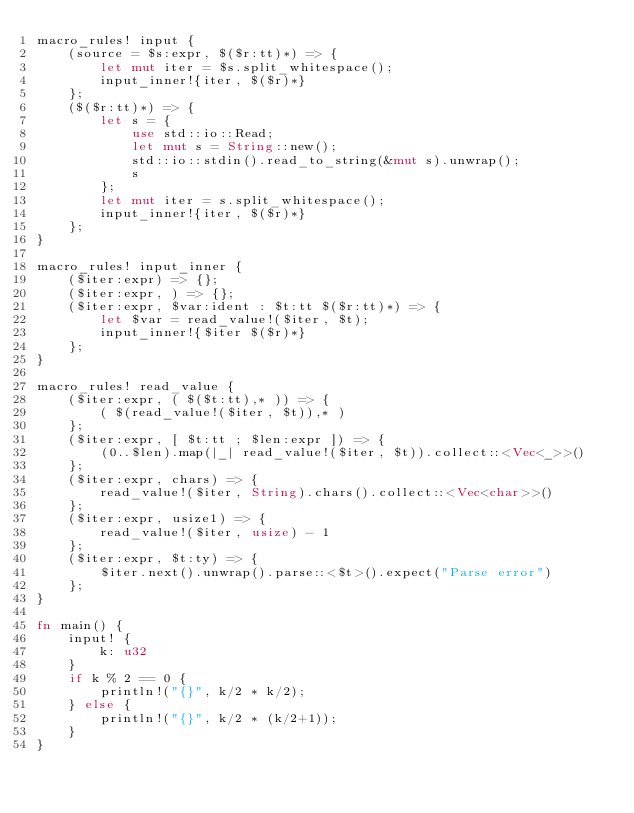Convert code to text. <code><loc_0><loc_0><loc_500><loc_500><_Rust_>macro_rules! input {
    (source = $s:expr, $($r:tt)*) => {
        let mut iter = $s.split_whitespace();
        input_inner!{iter, $($r)*}
    };
    ($($r:tt)*) => {
        let s = {
            use std::io::Read;
            let mut s = String::new();
            std::io::stdin().read_to_string(&mut s).unwrap();
            s
        };
        let mut iter = s.split_whitespace();
        input_inner!{iter, $($r)*}
    };
}

macro_rules! input_inner {
    ($iter:expr) => {};
    ($iter:expr, ) => {};
    ($iter:expr, $var:ident : $t:tt $($r:tt)*) => {
        let $var = read_value!($iter, $t);
        input_inner!{$iter $($r)*}
    };
}

macro_rules! read_value {
    ($iter:expr, ( $($t:tt),* )) => {
        ( $(read_value!($iter, $t)),* )
    };
    ($iter:expr, [ $t:tt ; $len:expr ]) => {
        (0..$len).map(|_| read_value!($iter, $t)).collect::<Vec<_>>()
    };
    ($iter:expr, chars) => {
        read_value!($iter, String).chars().collect::<Vec<char>>()
    };
    ($iter:expr, usize1) => {
        read_value!($iter, usize) - 1
    };
    ($iter:expr, $t:ty) => {
        $iter.next().unwrap().parse::<$t>().expect("Parse error")
    };
}

fn main() {
    input! {
        k: u32
    }
    if k % 2 == 0 {
        println!("{}", k/2 * k/2);
    } else {
        println!("{}", k/2 * (k/2+1));
    }
}
</code> 